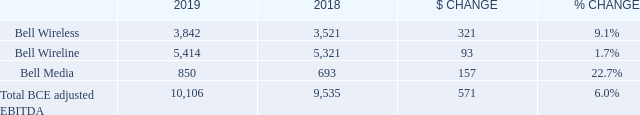4.6 Adjusted EBITDA
BCE
BCE’s adjusted EBITDA grew by 6.0% in 2019, compared to 2018, attributable to growth from all three of our segments. Higher revenues coupled with reduced operating expenses drove the year-over-year growth in adjusted EBITDA. This corresponded to an adjusted EBITDA margin of 42.2% in 2019, up 1.6 pts over last year, mainly driven by the favourable impact from the adoption of IFRS 16 in 2019, and greater service revenue flow-through, moderated by greater low-margin product sales in our total revenue base.
How much did BCE's adjusted EBITDA grow by in 2019? 6.0%. What was the $ CHANGE in Bell Media? 157. What is the adjusted EBITDA margin in 2019? 42.2%. What is the total Adjusted EBITDA for Bell Wireless in 2018 and 2019? 3,842+3,521
Answer: 7363. What is the percentage of Bell Wireline of the total BCE adjusted EBITDA in 2019?
Answer scale should be: percent. 5,414/10,106
Answer: 53.57. What is the difference in the Adjusted EBITDA for Bell Wireless and Bell Wireline in 2018? 5,321-3,521
Answer: 1800. 